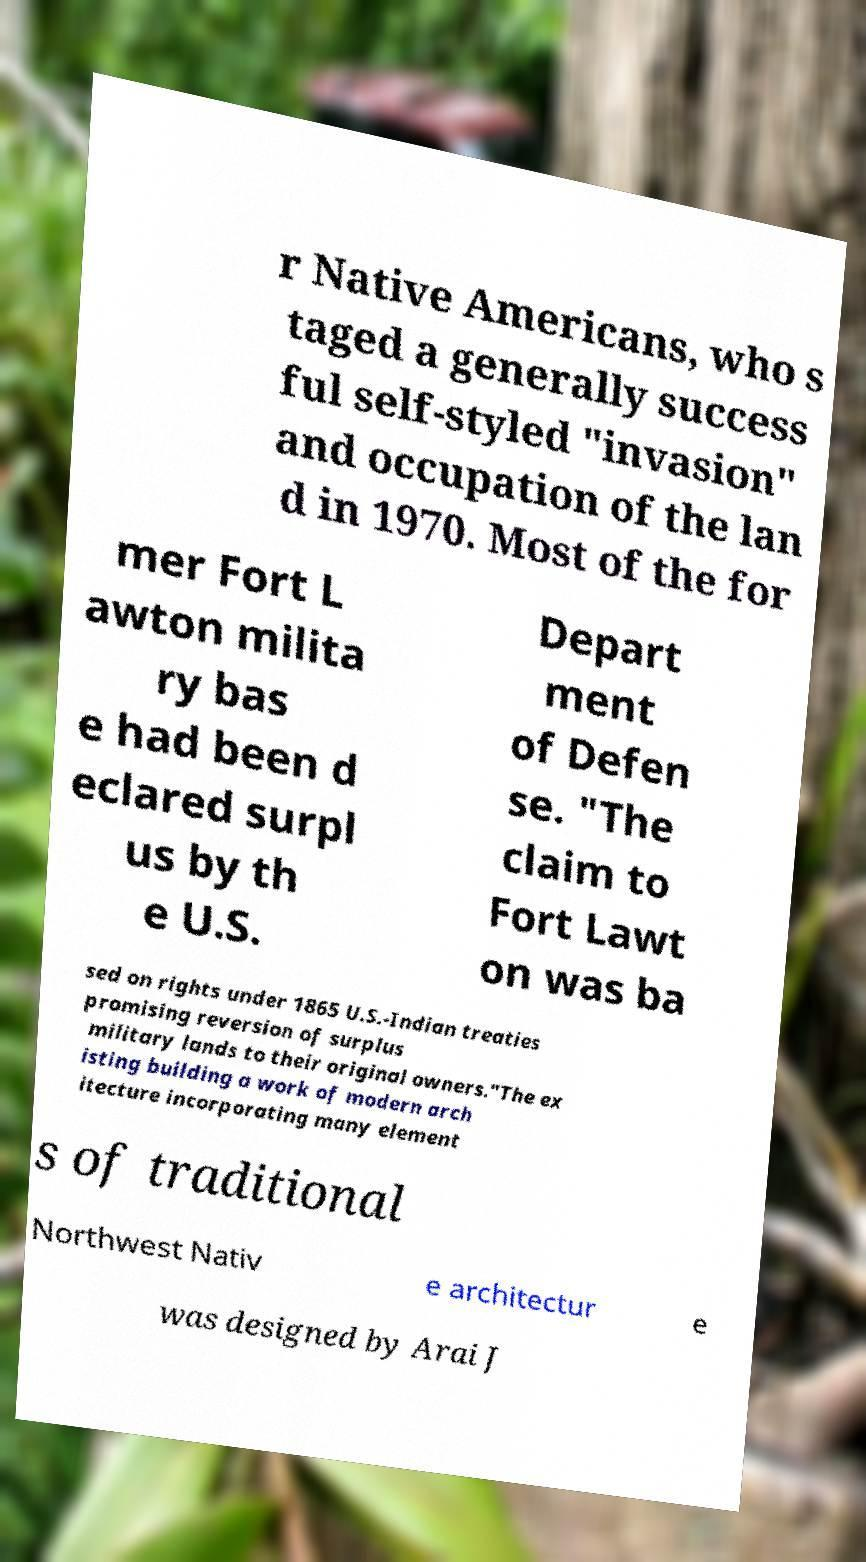Can you accurately transcribe the text from the provided image for me? r Native Americans, who s taged a generally success ful self-styled "invasion" and occupation of the lan d in 1970. Most of the for mer Fort L awton milita ry bas e had been d eclared surpl us by th e U.S. Depart ment of Defen se. "The claim to Fort Lawt on was ba sed on rights under 1865 U.S.-Indian treaties promising reversion of surplus military lands to their original owners."The ex isting building a work of modern arch itecture incorporating many element s of traditional Northwest Nativ e architectur e was designed by Arai J 